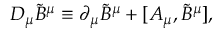<formula> <loc_0><loc_0><loc_500><loc_500>D _ { \mu } \tilde { B } ^ { \mu } \equiv \partial _ { \mu } \tilde { B } ^ { \mu } + [ A _ { \mu } , \tilde { B } ^ { \mu } ] ,</formula> 